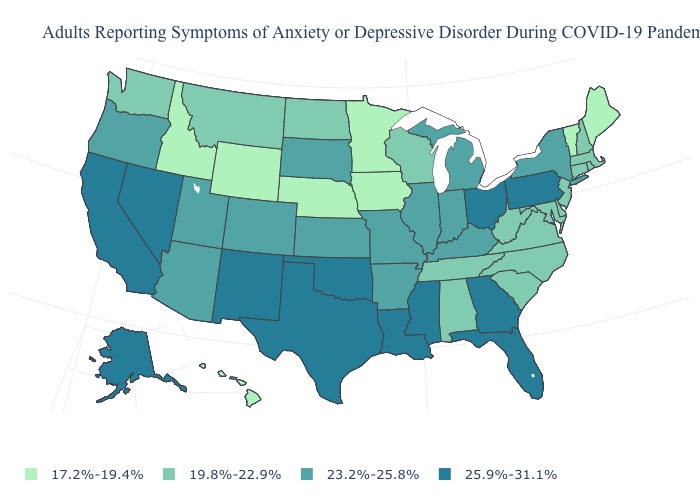Is the legend a continuous bar?
Answer briefly. No. Name the states that have a value in the range 19.8%-22.9%?
Concise answer only. Alabama, Connecticut, Delaware, Maryland, Massachusetts, Montana, New Hampshire, New Jersey, North Carolina, North Dakota, Rhode Island, South Carolina, Tennessee, Virginia, Washington, West Virginia, Wisconsin. What is the lowest value in the West?
Keep it brief. 17.2%-19.4%. What is the value of Missouri?
Keep it brief. 23.2%-25.8%. Name the states that have a value in the range 17.2%-19.4%?
Keep it brief. Hawaii, Idaho, Iowa, Maine, Minnesota, Nebraska, Vermont, Wyoming. Which states have the lowest value in the USA?
Be succinct. Hawaii, Idaho, Iowa, Maine, Minnesota, Nebraska, Vermont, Wyoming. Does Illinois have a higher value than Oklahoma?
Write a very short answer. No. Name the states that have a value in the range 25.9%-31.1%?
Concise answer only. Alaska, California, Florida, Georgia, Louisiana, Mississippi, Nevada, New Mexico, Ohio, Oklahoma, Pennsylvania, Texas. Is the legend a continuous bar?
Keep it brief. No. What is the highest value in the South ?
Be succinct. 25.9%-31.1%. Name the states that have a value in the range 25.9%-31.1%?
Short answer required. Alaska, California, Florida, Georgia, Louisiana, Mississippi, Nevada, New Mexico, Ohio, Oklahoma, Pennsylvania, Texas. Which states have the highest value in the USA?
Answer briefly. Alaska, California, Florida, Georgia, Louisiana, Mississippi, Nevada, New Mexico, Ohio, Oklahoma, Pennsylvania, Texas. Name the states that have a value in the range 19.8%-22.9%?
Answer briefly. Alabama, Connecticut, Delaware, Maryland, Massachusetts, Montana, New Hampshire, New Jersey, North Carolina, North Dakota, Rhode Island, South Carolina, Tennessee, Virginia, Washington, West Virginia, Wisconsin. Is the legend a continuous bar?
Concise answer only. No. 